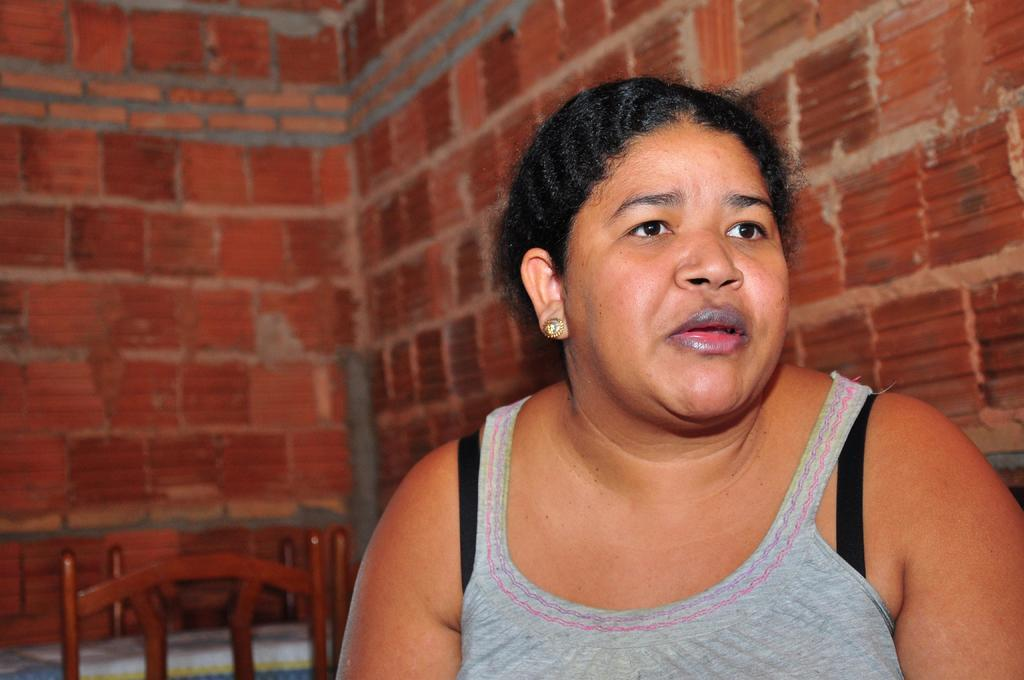Who is the main subject in the image? There is a woman in the image. What is located behind the woman? There are chairs behind the woman. What can be seen in the background of the image? There is a wall in the background of the image. How many mice can be seen running along the edge of the sky in the image? There are no mice or sky present in the image; it features a woman and chairs with a wall in the background. 